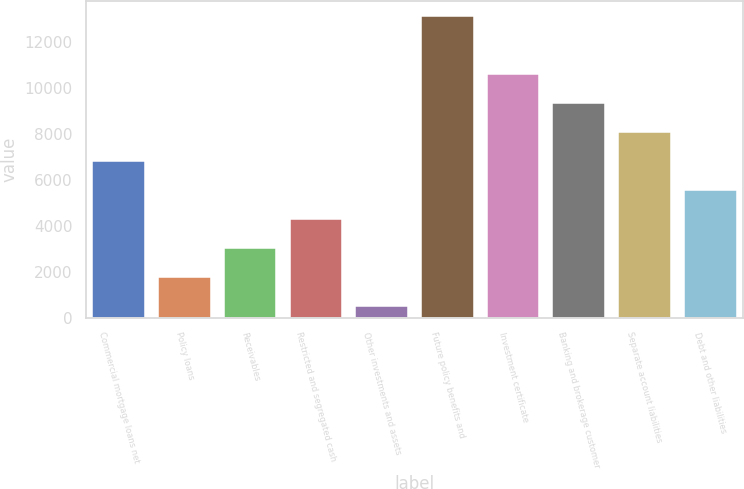Convert chart. <chart><loc_0><loc_0><loc_500><loc_500><bar_chart><fcel>Commercial mortgage loans net<fcel>Policy loans<fcel>Receivables<fcel>Restricted and segregated cash<fcel>Other investments and assets<fcel>Future policy benefits and<fcel>Investment certificate<fcel>Banking and brokerage customer<fcel>Separate account liabilities<fcel>Debt and other liabilities<nl><fcel>6818.5<fcel>1780.5<fcel>3040<fcel>4299.5<fcel>521<fcel>13116<fcel>10597<fcel>9337.5<fcel>8078<fcel>5559<nl></chart> 